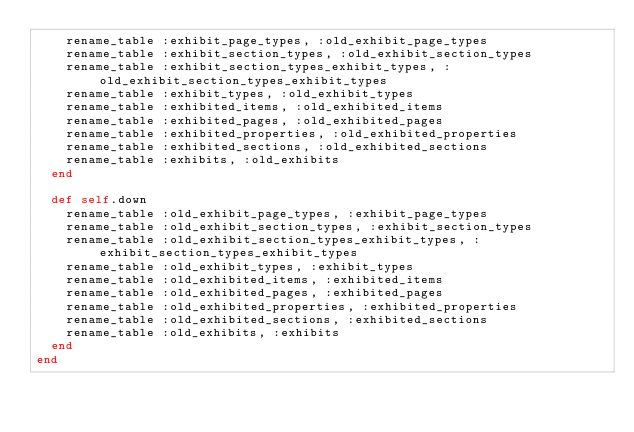<code> <loc_0><loc_0><loc_500><loc_500><_Ruby_>    rename_table :exhibit_page_types, :old_exhibit_page_types
    rename_table :exhibit_section_types, :old_exhibit_section_types
    rename_table :exhibit_section_types_exhibit_types, :old_exhibit_section_types_exhibit_types
    rename_table :exhibit_types, :old_exhibit_types
    rename_table :exhibited_items, :old_exhibited_items
    rename_table :exhibited_pages, :old_exhibited_pages
    rename_table :exhibited_properties, :old_exhibited_properties
    rename_table :exhibited_sections, :old_exhibited_sections
    rename_table :exhibits, :old_exhibits
  end

  def self.down
    rename_table :old_exhibit_page_types, :exhibit_page_types
    rename_table :old_exhibit_section_types, :exhibit_section_types
    rename_table :old_exhibit_section_types_exhibit_types, :exhibit_section_types_exhibit_types
    rename_table :old_exhibit_types, :exhibit_types
    rename_table :old_exhibited_items, :exhibited_items
    rename_table :old_exhibited_pages, :exhibited_pages
    rename_table :old_exhibited_properties, :exhibited_properties
    rename_table :old_exhibited_sections, :exhibited_sections
    rename_table :old_exhibits, :exhibits
  end
end
</code> 